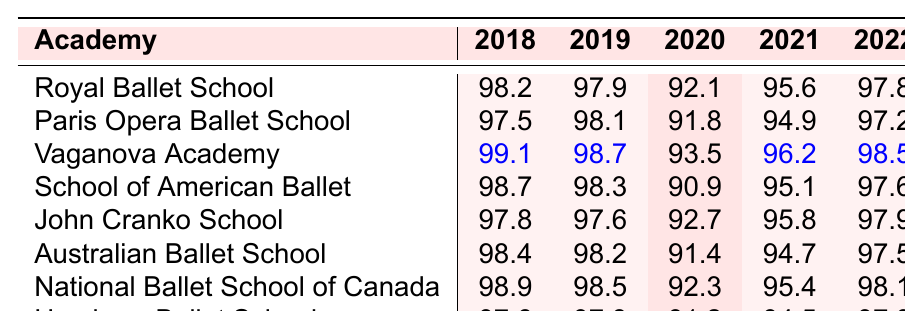What was the attendance rate of the Vaganova Academy in 2020? The attendance rate for the Vaganova Academy in 2020 can be directly found in the table under the column for the year 2020, which shows a value of 93.5.
Answer: 93.5 Which ballet academy had the highest attendance rate in 2019? To find the highest attendance rate in 2019, we look at the values in the 2019 column across all academies. The maximum value is 98.7, which belongs to the Vaganova Academy.
Answer: Vaganova Academy What is the attendance rate difference between the Royal Ballet School in 2018 and 2021? The attendance rate for the Royal Ballet School in 2018 is 98.2, and in 2021 it is 95.6. The difference is calculated as 98.2 - 95.6 = 2.6.
Answer: 2.6 Is the attendance rate of the School of American Ballet in 2020 higher or lower than 91? The attendance rate for the School of American Ballet in 2020 is 90.9, which is lower than 91.
Answer: Lower What is the average attendance rate over the years for the Australian Ballet School? The attendance rates for the Australian Ballet School over the years are 98.4, 98.2, 91.4, 94.7, and 97.5. Summing these gives 98.4 + 98.2 + 91.4 + 94.7 + 97.5 = 480.2. Dividing by 5, the average is 480.2 / 5 = 96.04.
Answer: 96.04 Which academy had a consistent attendance rate of higher than 97% from 2018 to 2022? To find an academy with consistent attendance rates above 97%, we need to check each row across the years. The Royal Ballet School maintains rates above 97% every year: 98.2, 97.9, 92.1, 95.6, 97.8—only 92.1 drops below 97%. Since Vaganova and National Ballet School also show fluctuations, no academy meets the criteria for all five years.
Answer: None In 2022, what is the combined attendance rate for the Royal Ballet School and the Hamburg Ballet School? The attendance rates for the Royal Ballet School in 2022 is 97.8 and for the Hamburg Ballet School it is 97.3. Adding these together gives 97.8 + 97.3 = 195.1.
Answer: 195.1 Which academy improved its attendance rate the most from 2020 to 2021? To determine the improvement, we check the attendance rates from 2020 to 2021 for each academy. The shifts are: Royal Ballet (-0.5), Paris Opera Ballet (+3.1), Vaganova Academy (+2.7), School of American Ballet (+4.2), John Cranko School (+3.1), Australian Ballet (-4.9), National Ballet (+3.1), Hamburg Ballet (+3.3). The highest improvement is 4.2 for the School of American Ballet.
Answer: School of American Ballet What trend can you identify from the attendance rates of the National Ballet School of Canada over the years? Reviewing the attendance rates, we see: 98.9 (2018), 98.5 (2019), 92.3 (2020), 95.4 (2021), and 98.1 (2022). It initially declines in 2020, then increases again in 2022, indicating fluctuations rather than a stable trend.
Answer: Fluctuating rates 